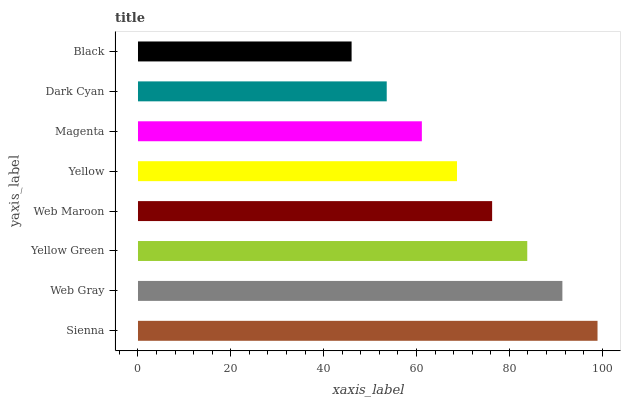Is Black the minimum?
Answer yes or no. Yes. Is Sienna the maximum?
Answer yes or no. Yes. Is Web Gray the minimum?
Answer yes or no. No. Is Web Gray the maximum?
Answer yes or no. No. Is Sienna greater than Web Gray?
Answer yes or no. Yes. Is Web Gray less than Sienna?
Answer yes or no. Yes. Is Web Gray greater than Sienna?
Answer yes or no. No. Is Sienna less than Web Gray?
Answer yes or no. No. Is Web Maroon the high median?
Answer yes or no. Yes. Is Yellow the low median?
Answer yes or no. Yes. Is Dark Cyan the high median?
Answer yes or no. No. Is Web Gray the low median?
Answer yes or no. No. 